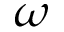Convert formula to latex. <formula><loc_0><loc_0><loc_500><loc_500>\omega</formula> 